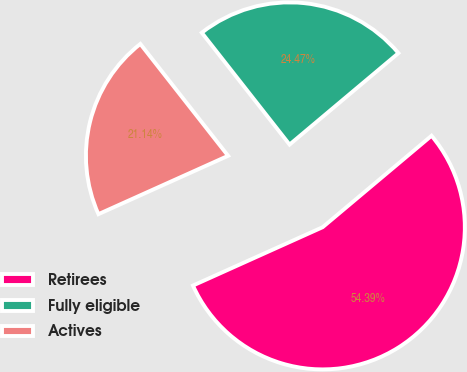Convert chart to OTSL. <chart><loc_0><loc_0><loc_500><loc_500><pie_chart><fcel>Retirees<fcel>Fully eligible<fcel>Actives<nl><fcel>54.39%<fcel>24.47%<fcel>21.14%<nl></chart> 